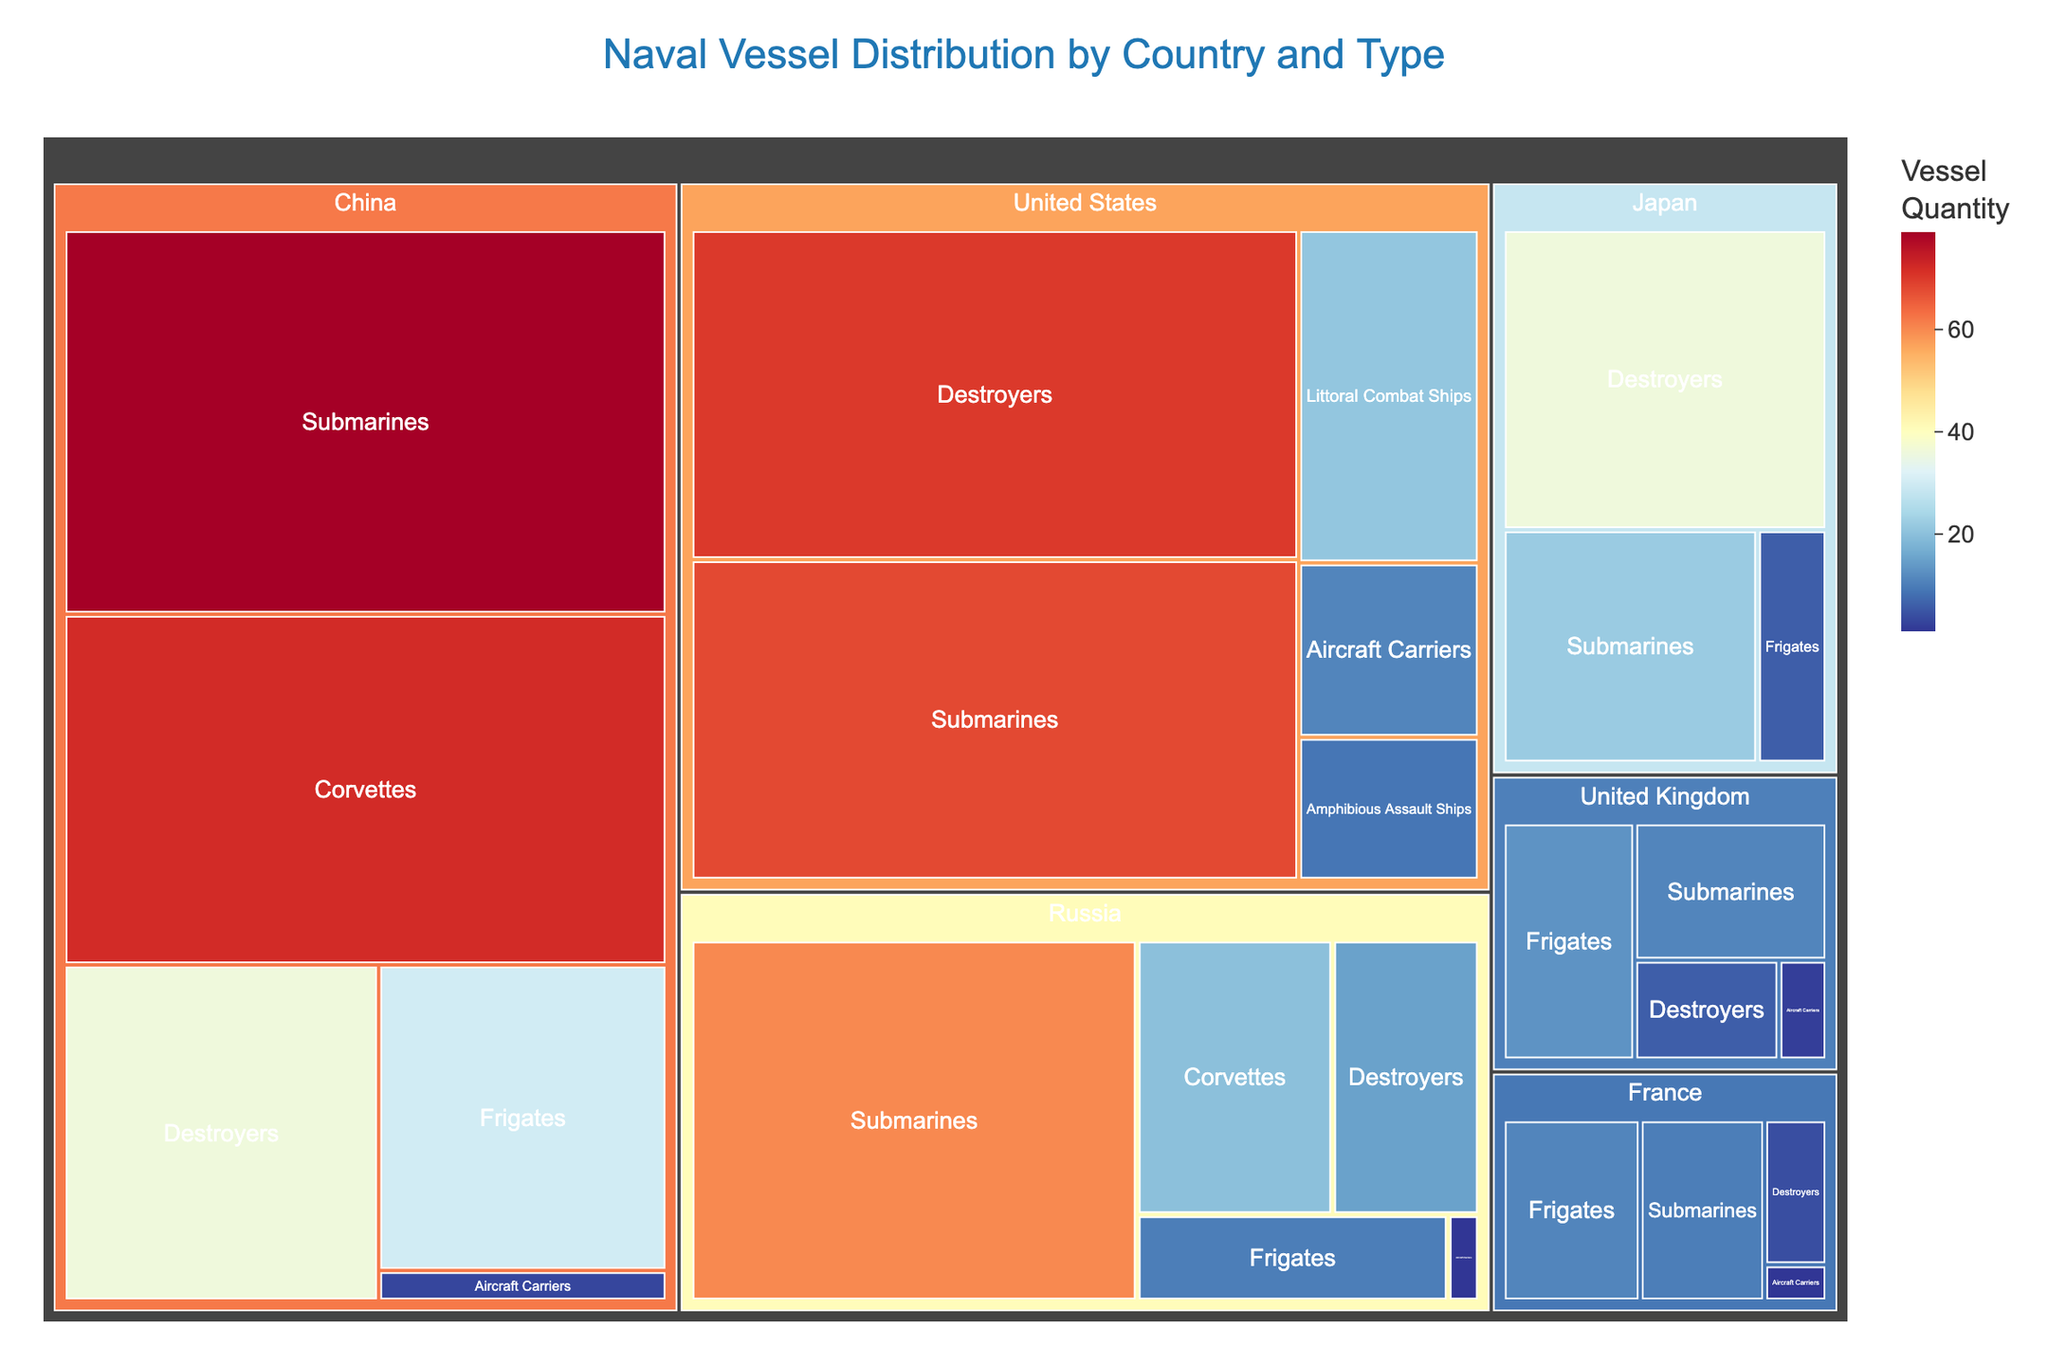How many submarines does China have compared to Japan? First, locate China's submarines section, which shows 79 vessels. Then, check the submarines section for Japan, which shows 22 vessels. Compare these two numbers to find the difference.
Answer: China has 57 more submarines than Japan What is the total number of naval vessels for Russia? Sum all the quantities of different types of vessels in the Russia section: Frigates (10), Destroyers (15), Corvettes (20), Submarines (60), and Aircraft Carriers (1). Adding these quantities together gives 10 + 15 + 20 + 60 + 1 = 106 vessels.
Answer: 106 vessels Which country has the highest number of Aircraft Carriers? Look at the Aircraft Carriers sections for each country: Russia (1), United States (11), China (3), United Kingdom (2), and France (1). The United States has the highest number with 11 Aircraft Carriers.
Answer: United States Compare the number of Destroyers between the United Kingdom and Japan. Which country has more? Check the Destroyers section for the United Kingdom, which shows 6 Destroyers. Then, check Japan's Destroyers section, which shows 36 Destroyers. Japan has more Destroyers.
Answer: Japan What is the combined total number of vessels for the United States and France? Sum all the vessel quantities for the United States: Destroyers (70), Aircraft Carriers (11), Submarines (68), Amphibious Assault Ships (9), and Littoral Combat Ships (21). Adding these gives 70 + 11 + 68 + 9 + 21 = 179 vessels. Then, sum all the vessel quantities for France: Frigates (11), Destroyers (4), Submarines (10), and Aircraft Carriers (1). Adding these gives 11 + 4 + 10 + 1 = 26 vessels. Finally, add the totals for the United States and France: 179 + 26 = 205 vessels.
Answer: 205 vessels How many more Corvettes does China have compared to Russia? Check China's Corvettes section, which indicates 72 Corvettes. Then, look at Russia's Corvettes section, which shows 20 Corvettes. Subtract Russia's Corvettes from China's: 72 - 20 = 52.
Answer: 52 Corvettes Which country has the smallest number of Frigates? Look at the Frigates sections for each country: Russia (10), China (30), United Kingdom (13), France (11), and Japan (6). Japan has the smallest number of Frigates with 6.
Answer: Japan How do the numbers of Submarines compare between the United States and China? Check the Submarines section for the United States, showing 68 Submarines, and for China, showing 79 Submarines. China has more Submarines than the United States.
Answer: China has more Submarines What is the average number of vessels per category for the United Kingdom? Sum the quantities of the vessels for the United Kingdom: Frigates (13), Destroyers (6), Submarines (11), and Aircraft Carriers (2). Adding these gives 13 + 6 + 11 + 2 = 32. The United Kingdom has 4 vessel categories, so divide the total by 4: 32 / 4 = 8.
Answer: 8 vessels per category 